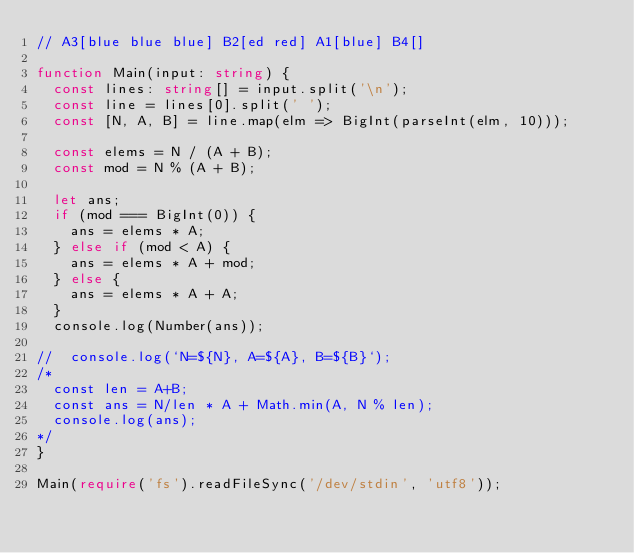Convert code to text. <code><loc_0><loc_0><loc_500><loc_500><_TypeScript_>// A3[blue blue blue] B2[ed red] A1[blue] B4[]

function Main(input: string) {
  const lines: string[] = input.split('\n');
  const line = lines[0].split(' ');
  const [N, A, B] = line.map(elm => BigInt(parseInt(elm, 10)));

  const elems = N / (A + B);
  const mod = N % (A + B);

  let ans;
  if (mod === BigInt(0)) {
    ans = elems * A;
  } else if (mod < A) {
    ans = elems * A + mod;
  } else {
    ans = elems * A + A;
  }
  console.log(Number(ans));

//  console.log(`N=${N}, A=${A}, B=${B}`);
/*
  const len = A+B;
  const ans = N/len * A + Math.min(A, N % len);
  console.log(ans);
*/
}

Main(require('fs').readFileSync('/dev/stdin', 'utf8'));
</code> 